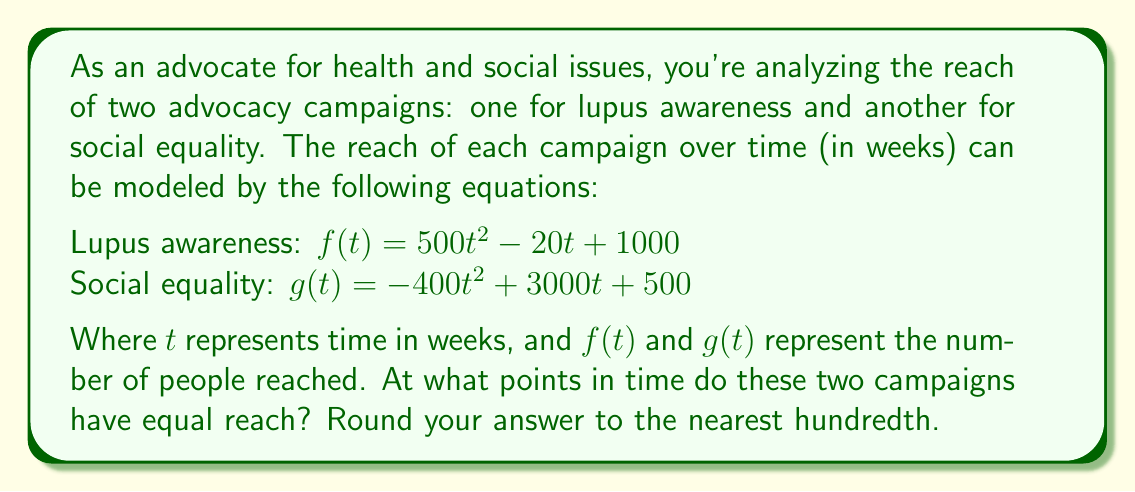Solve this math problem. To find the points where the two campaigns have equal reach, we need to solve the equation $f(t) = g(t)$:

1) Set up the equation:
   $500t^2 - 20t + 1000 = -400t^2 + 3000t + 500$

2) Rearrange to standard form:
   $500t^2 - 20t + 1000 + 400t^2 - 3000t - 500 = 0$
   $900t^2 - 3020t + 500 = 0$

3) Divide all terms by 20 to simplify:
   $45t^2 - 151t + 25 = 0$

4) This is a quadratic equation in the form $at^2 + bt + c = 0$, where:
   $a = 45$, $b = -151$, and $c = 25$

5) Use the quadratic formula: $t = \frac{-b \pm \sqrt{b^2 - 4ac}}{2a}$

6) Substitute the values:
   $t = \frac{151 \pm \sqrt{(-151)^2 - 4(45)(25)}}{2(45)}$

7) Simplify:
   $t = \frac{151 \pm \sqrt{22801 - 4500}}{90}$
   $t = \frac{151 \pm \sqrt{18301}}{90}$

8) Calculate the two solutions:
   $t_1 = \frac{151 + \sqrt{18301}}{90} \approx 3.31$
   $t_2 = \frac{151 - \sqrt{18301}}{90} \approx 0.05$

Therefore, the campaigns have equal reach at approximately 0.05 weeks and 3.31 weeks.
Answer: 0.05 weeks and 3.31 weeks 